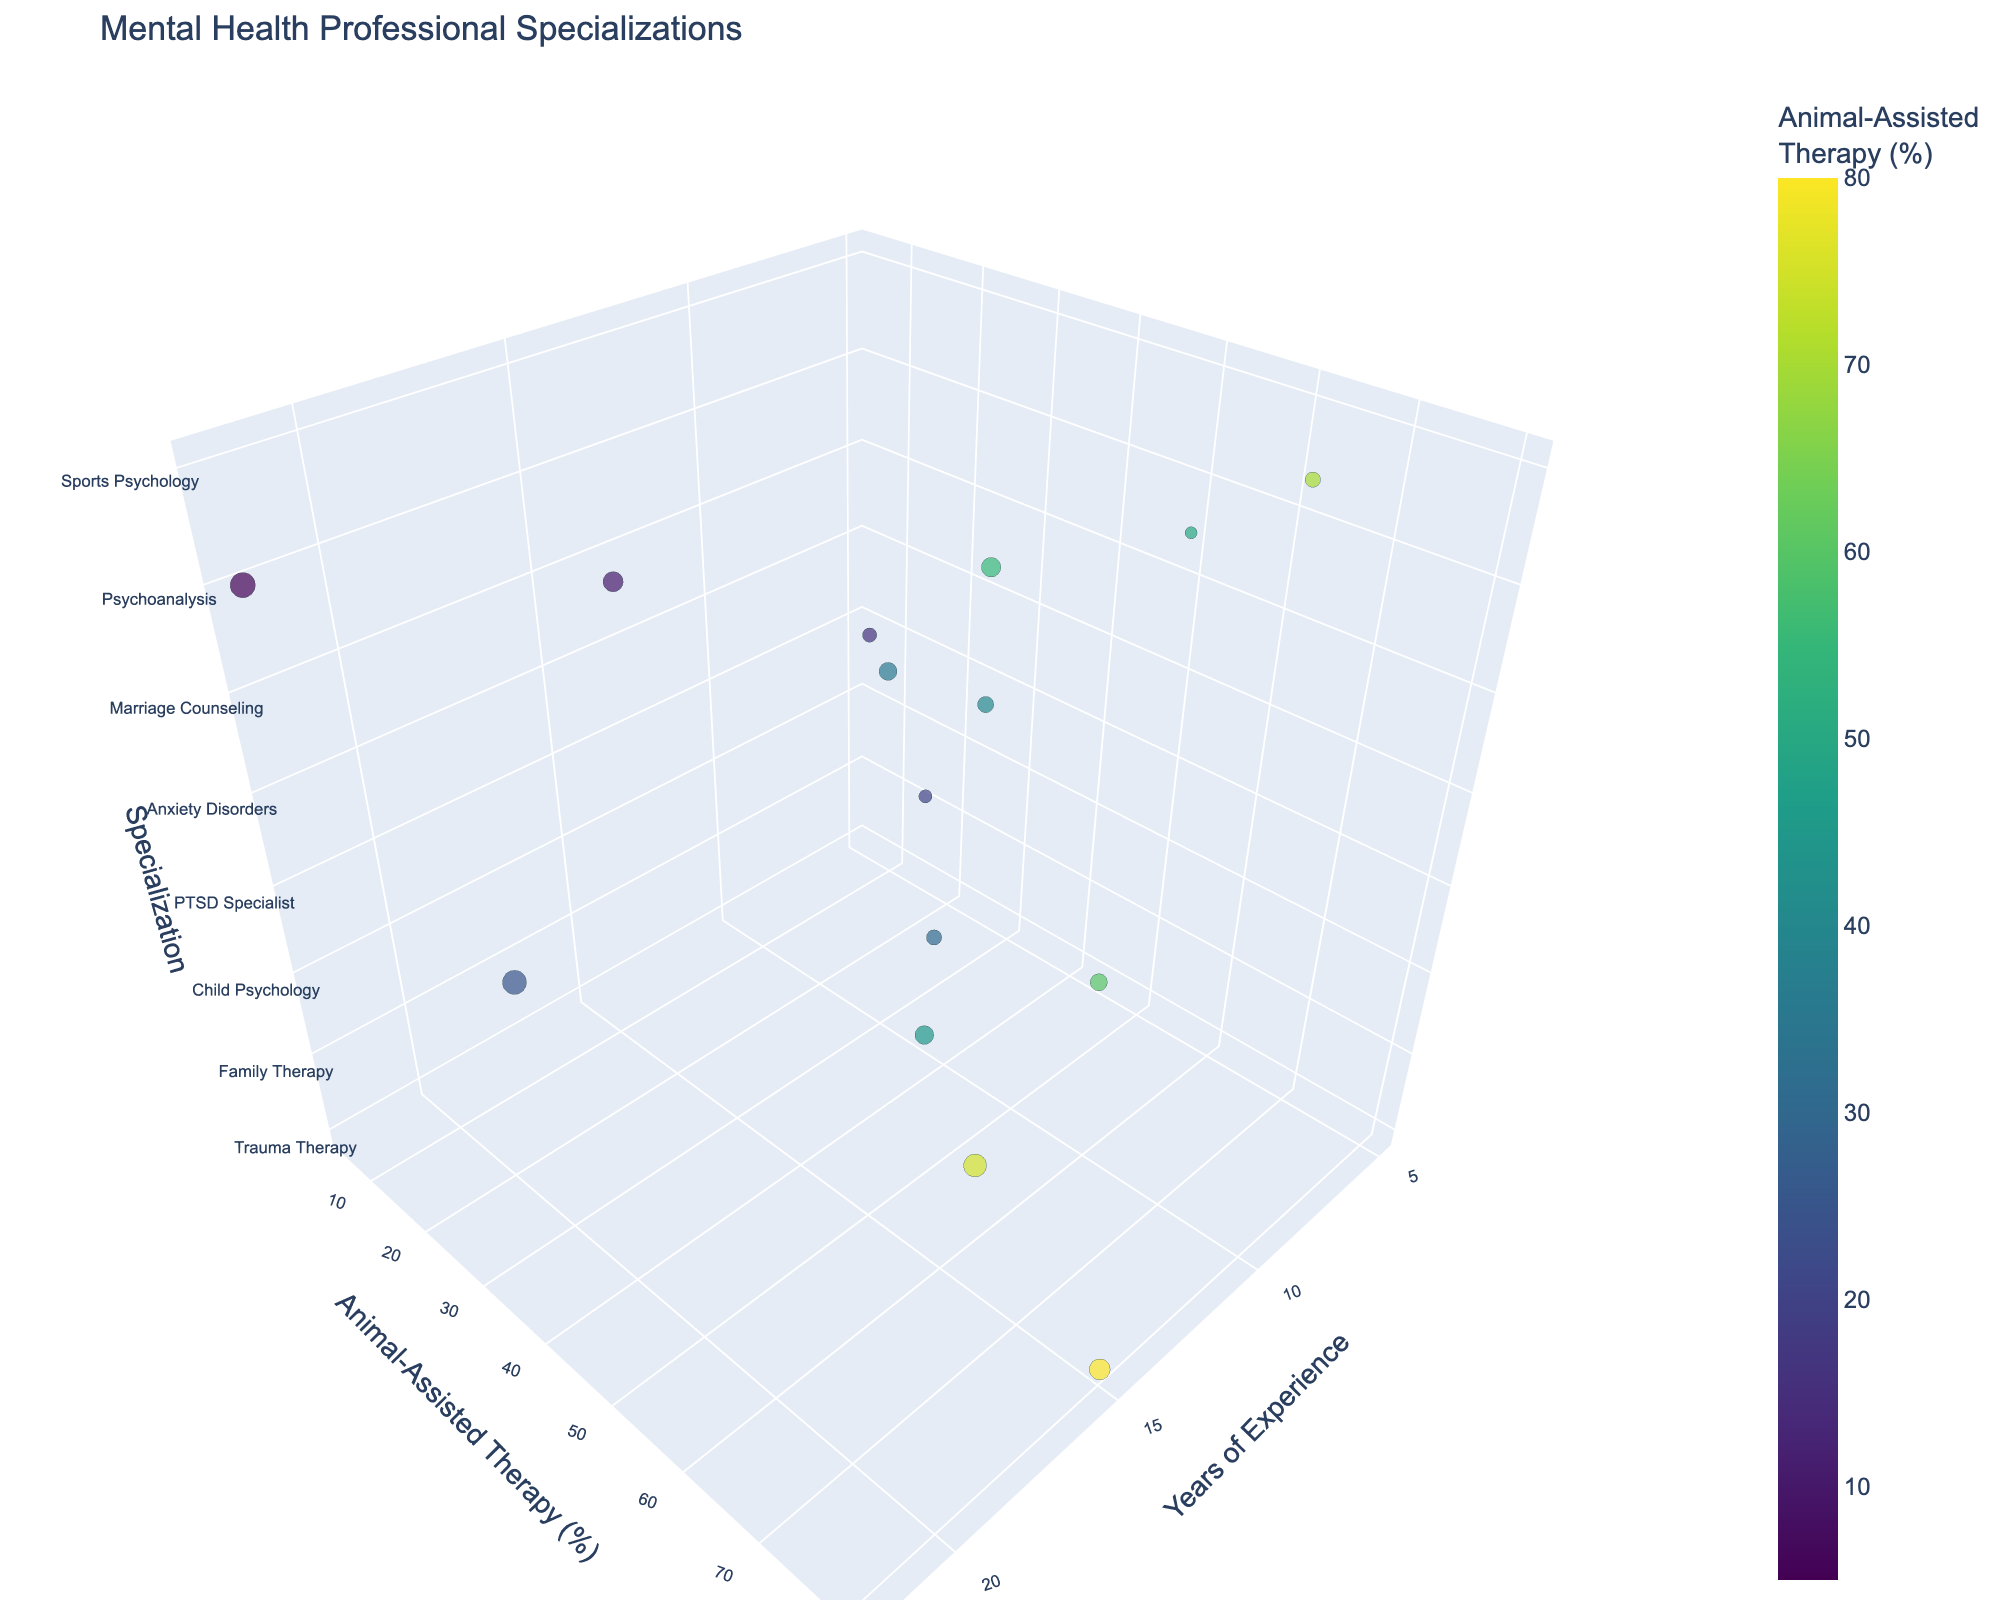What is the title of the figure? The title is usually found at the top of the figure and provides a summary of what the figure is about.
Answer: Mental Health Professional Specializations What does the x-axis represent? The label on the x-axis indicates the measure being represented along this axis. In this figure, the x-axis is labeled "Years of Experience."
Answer: Years of Experience Which specialization has the highest percentage of animal-assisted therapy incorporated? To determine this, look for the data point with the highest value on the y-axis which represents "Animal-Assisted Therapy (%)".
Answer: Trauma Therapy Which specialization has the highest number of years of experience? Check the x-axis where "Years of Experience" is plotted for the data point that represents the highest value.
Answer: Psychoanalysis What is the color of the data point representing Marriage Counseling? The color corresponds to the percentage of Animal-Assisted Therapy. Locate the Marriage Counseling point and note the color.
Answer: Dark color (closer to 10% on the Viridis color scale) Which specialization incorporates less than 20% of animal-assisted therapy? Name at least two. Locate data points with y-axis values less than 20% and identify their corresponding specializations.
Answer: Addiction Counseling, Eating Disorders How many specializations incorporate animal-assisted therapy at a rate of 50% or above? Count the number of data points on the y-axis that are at or above the 50% mark.
Answer: Seven What is the difference in years of experience between the PTSD Specialist and Behavioral Therapy specializations? Locate the values on the x-axis for both PTSD Specialist (18 years) and Behavioral Therapy (5 years), then subtract.
Answer: 13 years Compare the years of experience between Trauma Therapy and Family Therapy. Which one has more years and by how many? Identify their positions on the x-axis: Trauma Therapy (15 years) and Family Therapy (12 years). Subtract to find the difference.
Answer: Trauma Therapy by 3 years 